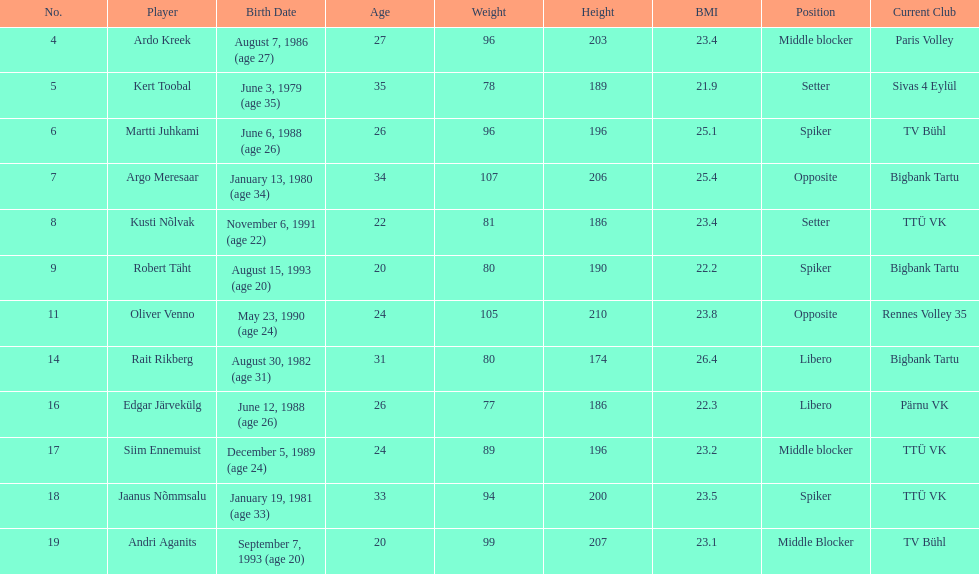Which player is taller than andri agantis? Oliver Venno. 